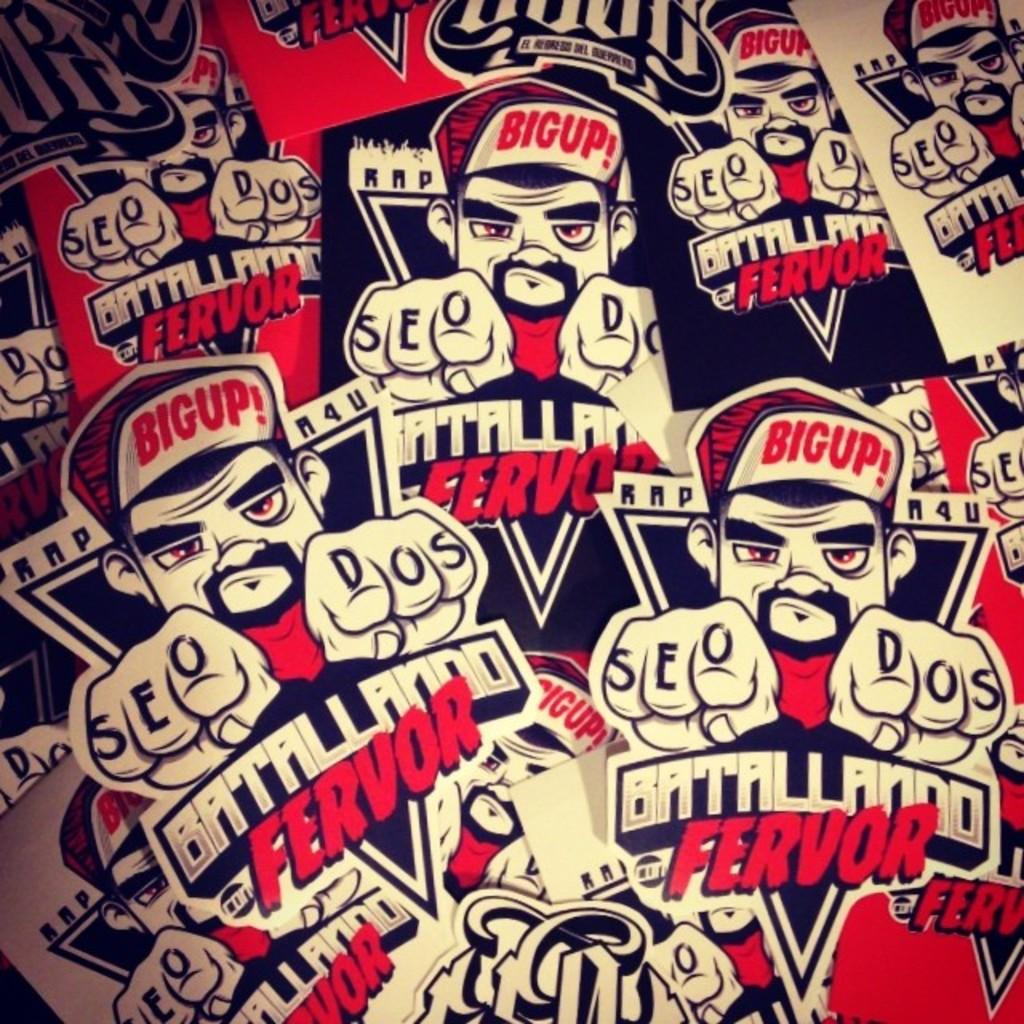<image>
Give a short and clear explanation of the subsequent image. a bunch of labels that says 'batallando fervor' on them 